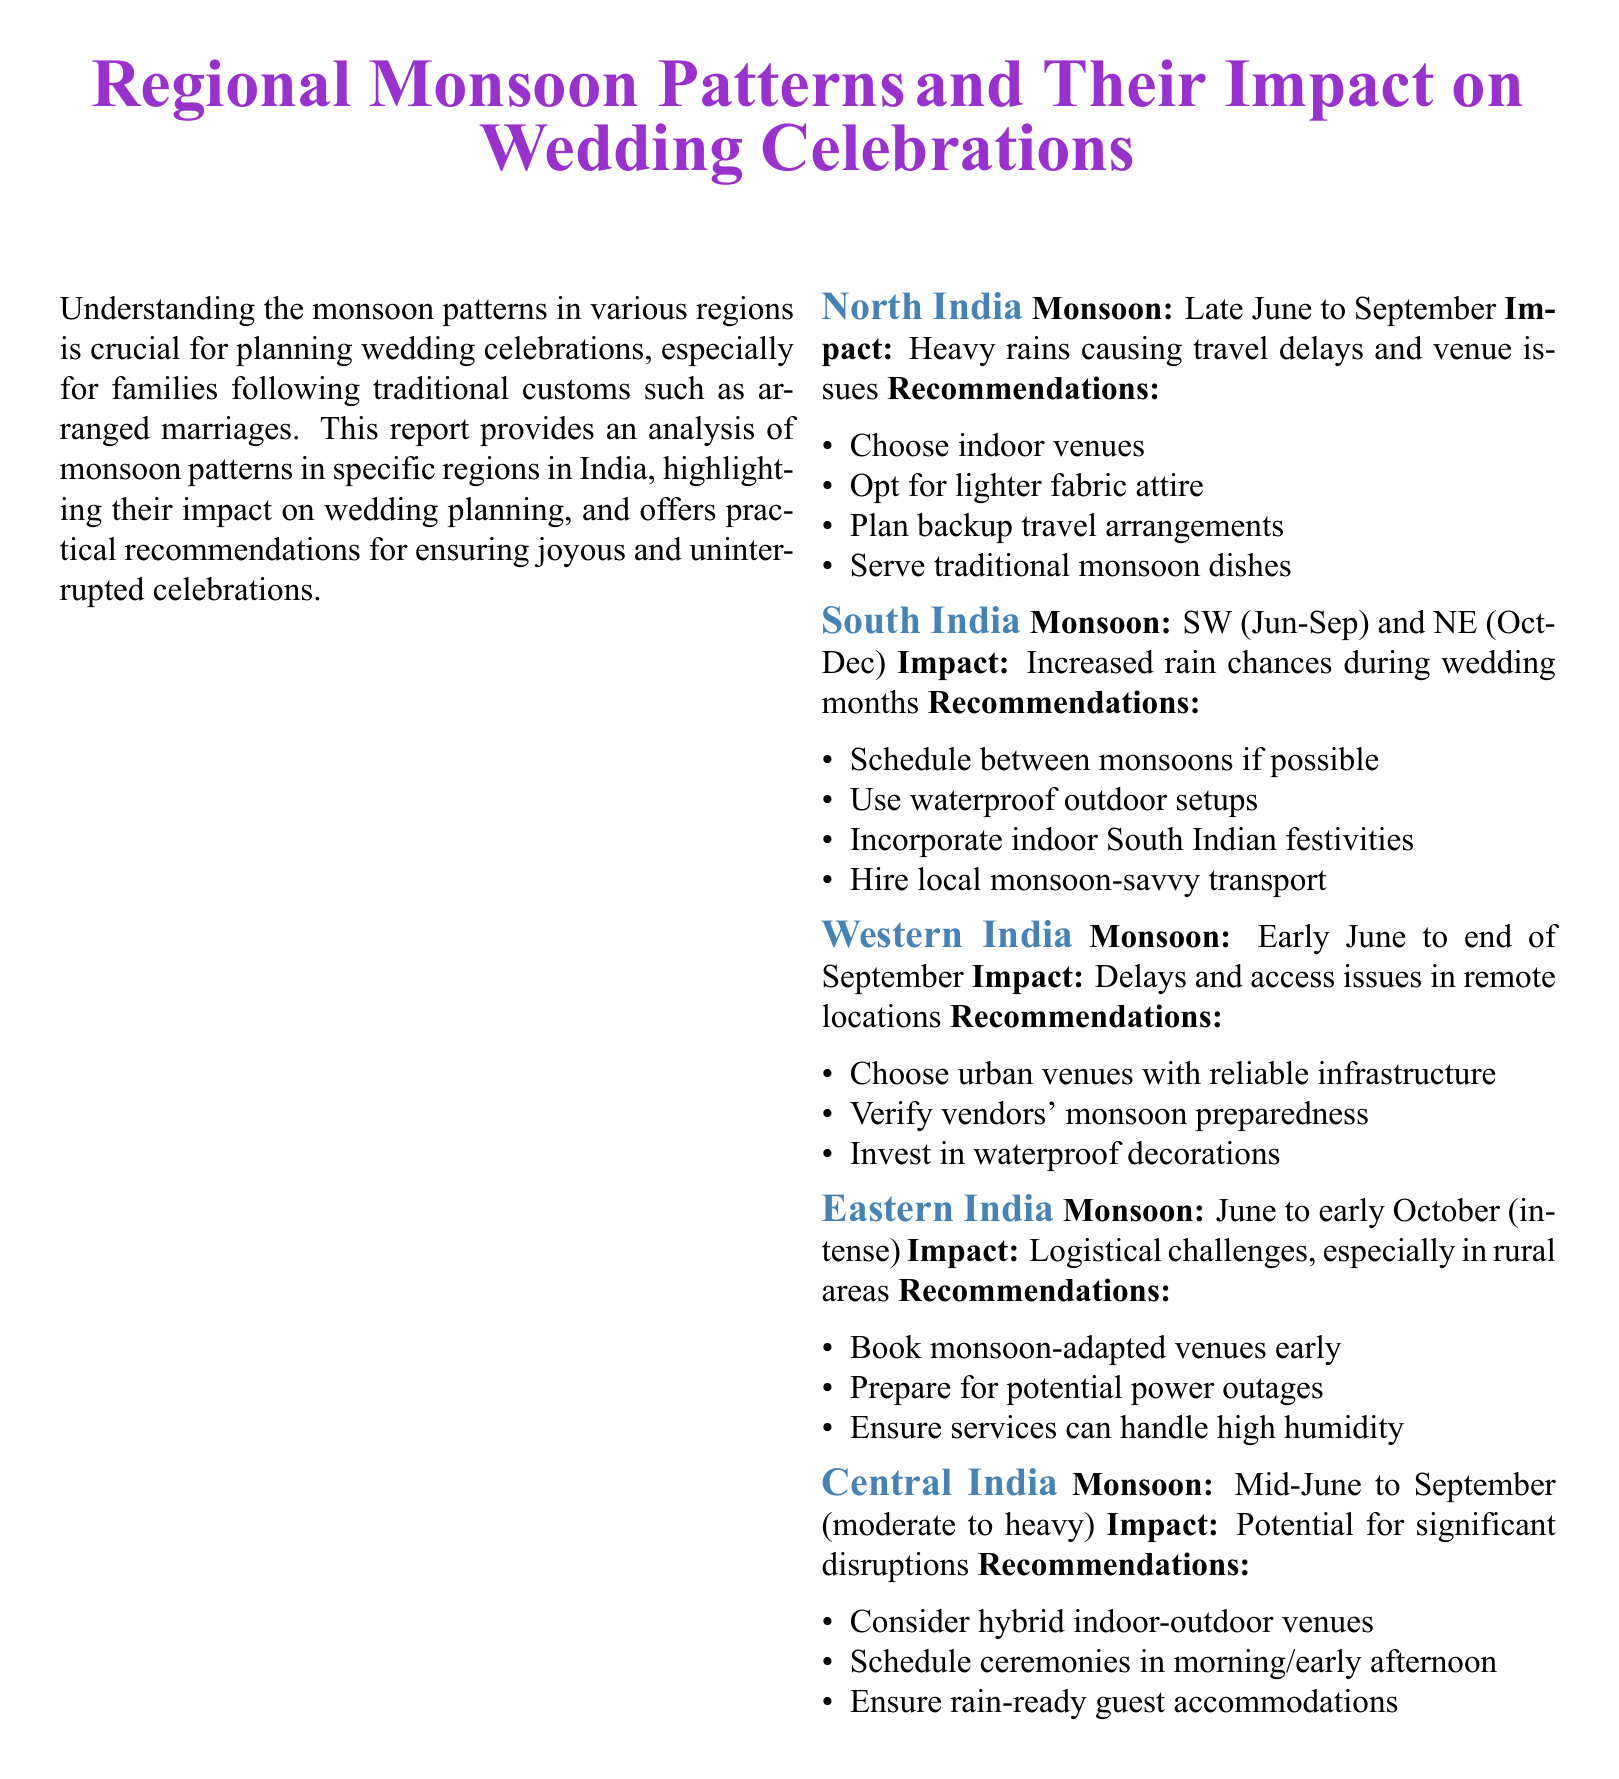what months constitute the monsoon season in North India? North India experiences monsoon from Late June to September.
Answer: Late June to September what is the primary impact of the monsoon on weddings in Western India? The primary impact is delays and access issues in remote locations.
Answer: Delays and access issues what are two recommendations for wedding celebrations in South India during the monsoon? Recommendations include scheduling between monsoons and using waterproof outdoor setups.
Answer: Schedule between monsoons, waterproof outdoor setups how long is the monsoon season in Eastern India? The monsoon period lasts from June to early October, described as intense.
Answer: June to early October what is a unique recommendation for Central India weddings during monsoon? A unique recommendation is to consider hybrid indoor-outdoor venues.
Answer: Hybrid indoor-outdoor venues what is the overall conclusion of the report regarding wedding celebrations? The conclusion emphasizes understanding monsoon patterns to ensure smoother wedding celebrations.
Answer: Understanding monsoon patterns which region's recommendations suggest booking venues early? Eastern India's recommendations suggest booking monsoon-adapted venues early.
Answer: Eastern India what is a common issue faced by weddings in Northern India during the monsoon? A common issue is travel delays and venue issues due to heavy rains.
Answer: Travel delays and venue issues 